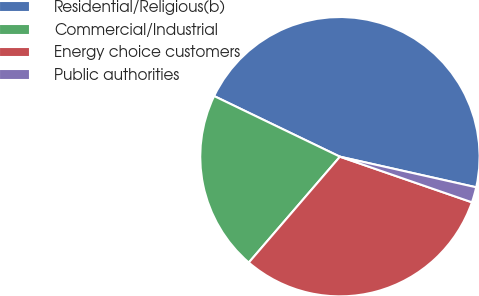<chart> <loc_0><loc_0><loc_500><loc_500><pie_chart><fcel>Residential/Religious(b)<fcel>Commercial/Industrial<fcel>Energy choice customers<fcel>Public authorities<nl><fcel>46.37%<fcel>20.84%<fcel>31.02%<fcel>1.78%<nl></chart> 